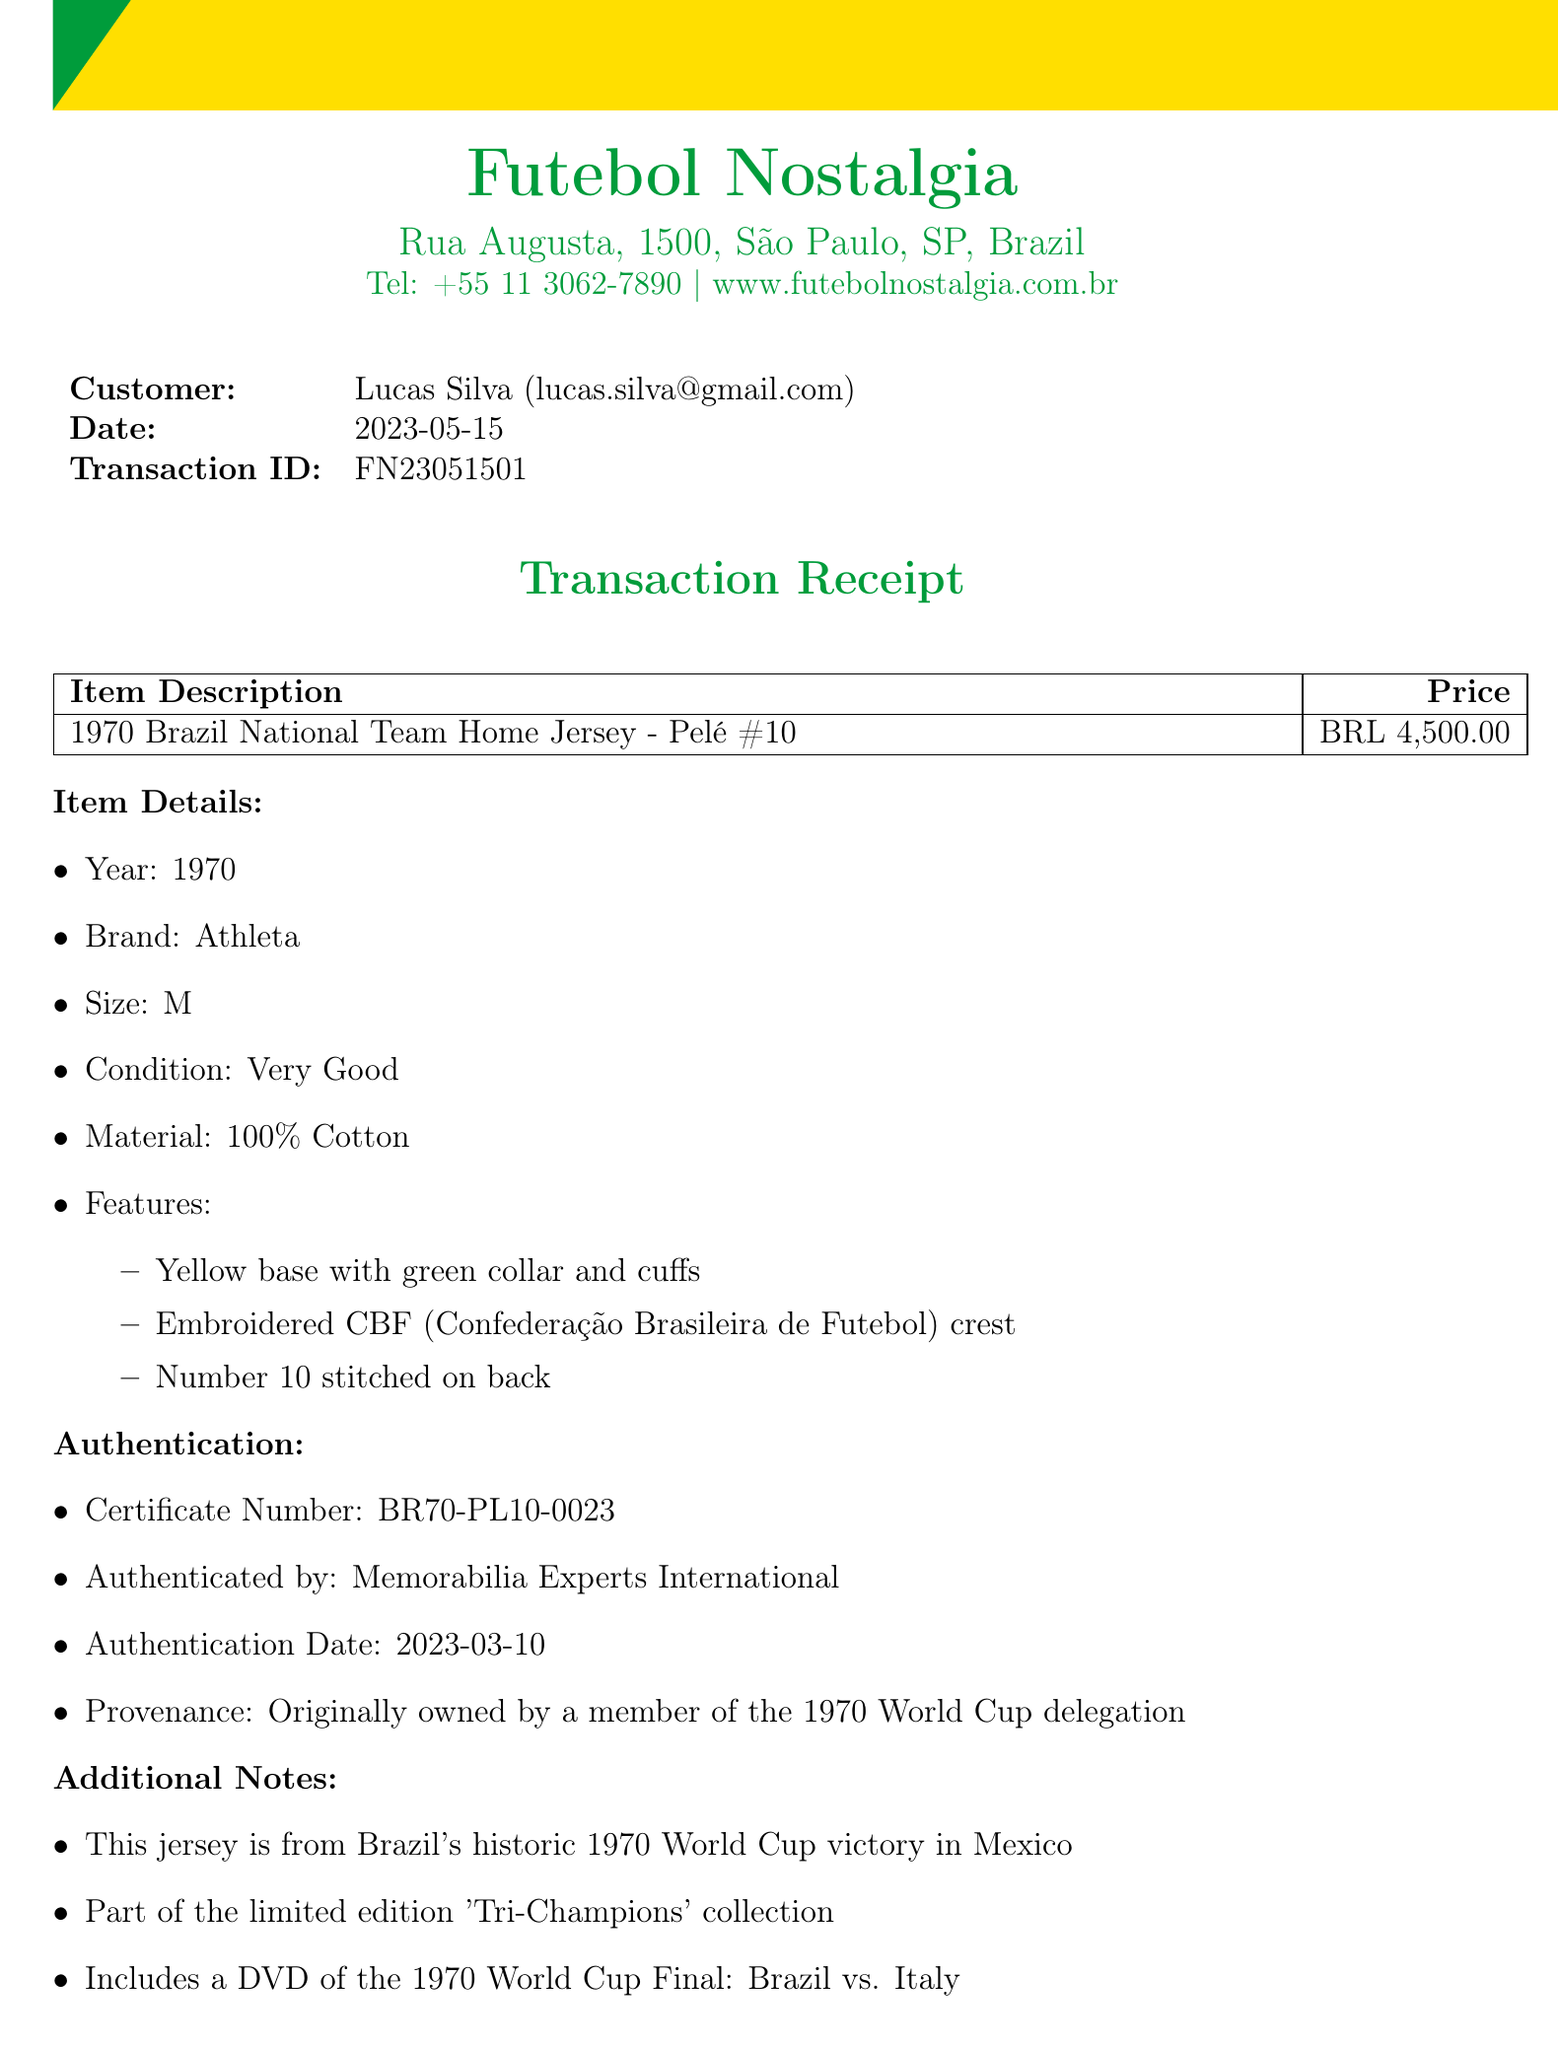What is the name of the shop? The shop name is mentioned at the top of the document as "Futebol Nostalgia."
Answer: Futebol Nostalgia What is the price of the jersey? The price of the jersey is listed in the item description section as "BRL 4,500.00."
Answer: BRL 4,500.00 Who is the authenticated by? The authentication section states that the item was authenticated by "Memorabilia Experts International."
Answer: Memorabilia Experts International What is the transaction date? The transaction date is specified in the customer section as "2023-05-15."
Answer: 2023-05-15 What is the return policy? The return policy is described in the document stating it is for "30-day return policy for store credit only."
Answer: 30-day return policy for store credit only What size is the jersey? The item details section includes the size of the jersey, which is listed as "M."
Answer: M What is included with the jersey? The additional notes mention that the purchase includes "a DVD of the 1970 World Cup Final: Brazil vs. Italy."
Answer: a DVD of the 1970 World Cup Final: Brazil vs. Italy When was the authentication date? The authentication details specify the authentication date as "2023-03-10."
Answer: 2023-03-10 What year is the jersey from? The item details section states the year of the jersey as "1970."
Answer: 1970 